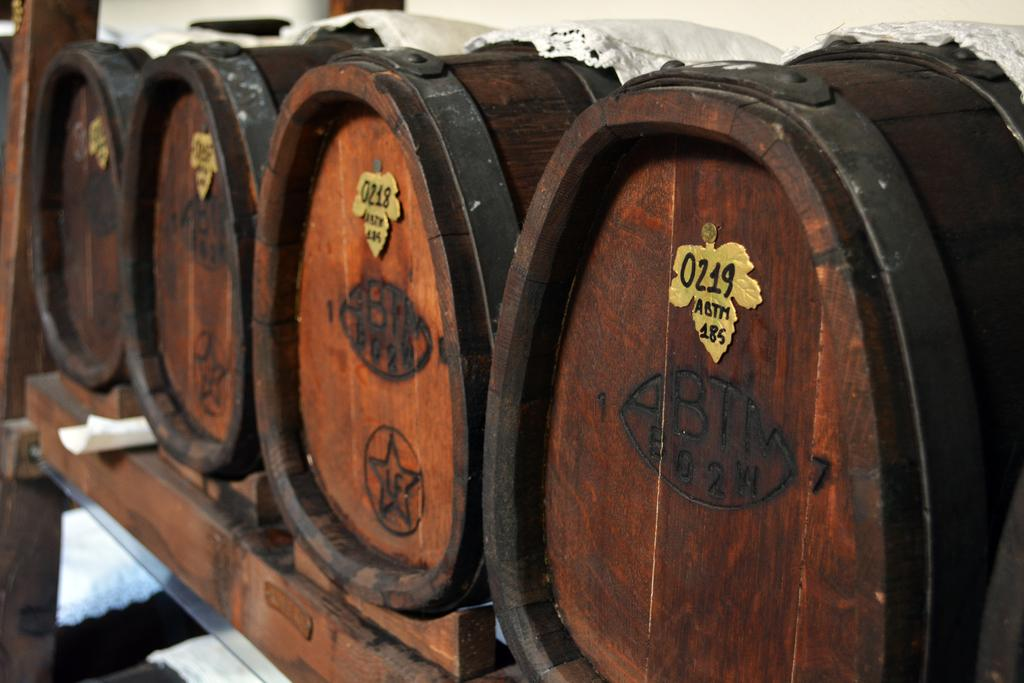What type of containers are present in the image? There are wooden barrels with batches in the image. How are the wooden barrels positioned? The wooden barrels are placed on a wooden stand. What is the color of the object in the image? There is a white object in the image. What can be seen at the top of the image? Clothes are visible at the top of the image. Can you tell me how many people are driving in the image? There is no reference to driving or any vehicles in the image, so it's not possible to determine the number of people driving. 